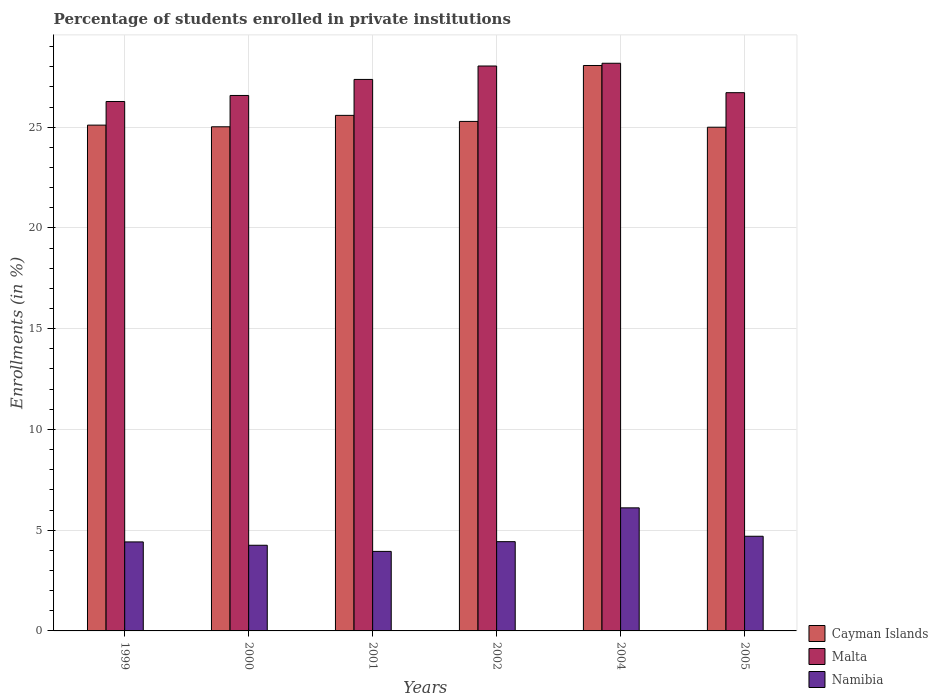How many different coloured bars are there?
Make the answer very short. 3. Are the number of bars on each tick of the X-axis equal?
Your response must be concise. Yes. How many bars are there on the 6th tick from the left?
Your answer should be compact. 3. How many bars are there on the 3rd tick from the right?
Keep it short and to the point. 3. What is the label of the 1st group of bars from the left?
Give a very brief answer. 1999. What is the percentage of trained teachers in Malta in 2004?
Offer a terse response. 28.17. Across all years, what is the maximum percentage of trained teachers in Cayman Islands?
Give a very brief answer. 28.06. Across all years, what is the minimum percentage of trained teachers in Namibia?
Provide a succinct answer. 3.95. In which year was the percentage of trained teachers in Namibia maximum?
Provide a succinct answer. 2004. In which year was the percentage of trained teachers in Malta minimum?
Offer a terse response. 1999. What is the total percentage of trained teachers in Cayman Islands in the graph?
Your response must be concise. 154.07. What is the difference between the percentage of trained teachers in Cayman Islands in 1999 and that in 2001?
Offer a very short reply. -0.48. What is the difference between the percentage of trained teachers in Malta in 2000 and the percentage of trained teachers in Cayman Islands in 2004?
Offer a very short reply. -1.49. What is the average percentage of trained teachers in Malta per year?
Ensure brevity in your answer.  27.19. In the year 2002, what is the difference between the percentage of trained teachers in Cayman Islands and percentage of trained teachers in Namibia?
Provide a short and direct response. 20.86. In how many years, is the percentage of trained teachers in Malta greater than 10 %?
Provide a short and direct response. 6. What is the ratio of the percentage of trained teachers in Cayman Islands in 1999 to that in 2004?
Ensure brevity in your answer.  0.89. Is the difference between the percentage of trained teachers in Cayman Islands in 2002 and 2004 greater than the difference between the percentage of trained teachers in Namibia in 2002 and 2004?
Your answer should be compact. No. What is the difference between the highest and the second highest percentage of trained teachers in Cayman Islands?
Your answer should be very brief. 2.48. What is the difference between the highest and the lowest percentage of trained teachers in Malta?
Your response must be concise. 1.9. Is the sum of the percentage of trained teachers in Malta in 2002 and 2005 greater than the maximum percentage of trained teachers in Namibia across all years?
Provide a short and direct response. Yes. What does the 1st bar from the left in 2002 represents?
Ensure brevity in your answer.  Cayman Islands. What does the 2nd bar from the right in 1999 represents?
Offer a terse response. Malta. Are all the bars in the graph horizontal?
Provide a succinct answer. No. How many years are there in the graph?
Your response must be concise. 6. Are the values on the major ticks of Y-axis written in scientific E-notation?
Make the answer very short. No. Does the graph contain any zero values?
Your answer should be compact. No. Does the graph contain grids?
Keep it short and to the point. Yes. How many legend labels are there?
Your answer should be compact. 3. What is the title of the graph?
Your answer should be very brief. Percentage of students enrolled in private institutions. Does "Turks and Caicos Islands" appear as one of the legend labels in the graph?
Ensure brevity in your answer.  No. What is the label or title of the X-axis?
Offer a terse response. Years. What is the label or title of the Y-axis?
Provide a succinct answer. Enrollments (in %). What is the Enrollments (in %) of Cayman Islands in 1999?
Keep it short and to the point. 25.1. What is the Enrollments (in %) in Malta in 1999?
Provide a succinct answer. 26.28. What is the Enrollments (in %) of Namibia in 1999?
Offer a terse response. 4.42. What is the Enrollments (in %) of Cayman Islands in 2000?
Your response must be concise. 25.02. What is the Enrollments (in %) in Malta in 2000?
Your answer should be compact. 26.58. What is the Enrollments (in %) of Namibia in 2000?
Provide a short and direct response. 4.25. What is the Enrollments (in %) in Cayman Islands in 2001?
Offer a very short reply. 25.59. What is the Enrollments (in %) in Malta in 2001?
Provide a short and direct response. 27.37. What is the Enrollments (in %) in Namibia in 2001?
Make the answer very short. 3.95. What is the Enrollments (in %) of Cayman Islands in 2002?
Keep it short and to the point. 25.29. What is the Enrollments (in %) of Malta in 2002?
Ensure brevity in your answer.  28.04. What is the Enrollments (in %) of Namibia in 2002?
Give a very brief answer. 4.43. What is the Enrollments (in %) in Cayman Islands in 2004?
Ensure brevity in your answer.  28.06. What is the Enrollments (in %) in Malta in 2004?
Ensure brevity in your answer.  28.17. What is the Enrollments (in %) in Namibia in 2004?
Provide a short and direct response. 6.11. What is the Enrollments (in %) in Malta in 2005?
Your answer should be compact. 26.71. What is the Enrollments (in %) of Namibia in 2005?
Give a very brief answer. 4.7. Across all years, what is the maximum Enrollments (in %) in Cayman Islands?
Your answer should be very brief. 28.06. Across all years, what is the maximum Enrollments (in %) of Malta?
Your response must be concise. 28.17. Across all years, what is the maximum Enrollments (in %) in Namibia?
Make the answer very short. 6.11. Across all years, what is the minimum Enrollments (in %) of Cayman Islands?
Your answer should be compact. 25. Across all years, what is the minimum Enrollments (in %) of Malta?
Provide a short and direct response. 26.28. Across all years, what is the minimum Enrollments (in %) in Namibia?
Offer a terse response. 3.95. What is the total Enrollments (in %) of Cayman Islands in the graph?
Make the answer very short. 154.07. What is the total Enrollments (in %) of Malta in the graph?
Your answer should be very brief. 163.15. What is the total Enrollments (in %) in Namibia in the graph?
Make the answer very short. 27.85. What is the difference between the Enrollments (in %) in Cayman Islands in 1999 and that in 2000?
Give a very brief answer. 0.08. What is the difference between the Enrollments (in %) in Malta in 1999 and that in 2000?
Make the answer very short. -0.3. What is the difference between the Enrollments (in %) of Namibia in 1999 and that in 2000?
Your answer should be compact. 0.17. What is the difference between the Enrollments (in %) of Cayman Islands in 1999 and that in 2001?
Keep it short and to the point. -0.48. What is the difference between the Enrollments (in %) in Malta in 1999 and that in 2001?
Provide a short and direct response. -1.09. What is the difference between the Enrollments (in %) of Namibia in 1999 and that in 2001?
Offer a terse response. 0.47. What is the difference between the Enrollments (in %) of Cayman Islands in 1999 and that in 2002?
Your answer should be very brief. -0.18. What is the difference between the Enrollments (in %) of Malta in 1999 and that in 2002?
Provide a succinct answer. -1.76. What is the difference between the Enrollments (in %) in Namibia in 1999 and that in 2002?
Your answer should be very brief. -0.01. What is the difference between the Enrollments (in %) of Cayman Islands in 1999 and that in 2004?
Ensure brevity in your answer.  -2.96. What is the difference between the Enrollments (in %) in Malta in 1999 and that in 2004?
Give a very brief answer. -1.9. What is the difference between the Enrollments (in %) of Namibia in 1999 and that in 2004?
Ensure brevity in your answer.  -1.69. What is the difference between the Enrollments (in %) in Cayman Islands in 1999 and that in 2005?
Provide a succinct answer. 0.1. What is the difference between the Enrollments (in %) in Malta in 1999 and that in 2005?
Your response must be concise. -0.44. What is the difference between the Enrollments (in %) of Namibia in 1999 and that in 2005?
Offer a very short reply. -0.28. What is the difference between the Enrollments (in %) of Cayman Islands in 2000 and that in 2001?
Keep it short and to the point. -0.57. What is the difference between the Enrollments (in %) in Malta in 2000 and that in 2001?
Give a very brief answer. -0.8. What is the difference between the Enrollments (in %) of Namibia in 2000 and that in 2001?
Give a very brief answer. 0.3. What is the difference between the Enrollments (in %) in Cayman Islands in 2000 and that in 2002?
Give a very brief answer. -0.27. What is the difference between the Enrollments (in %) of Malta in 2000 and that in 2002?
Ensure brevity in your answer.  -1.46. What is the difference between the Enrollments (in %) of Namibia in 2000 and that in 2002?
Provide a succinct answer. -0.18. What is the difference between the Enrollments (in %) of Cayman Islands in 2000 and that in 2004?
Your answer should be very brief. -3.04. What is the difference between the Enrollments (in %) of Malta in 2000 and that in 2004?
Offer a terse response. -1.6. What is the difference between the Enrollments (in %) in Namibia in 2000 and that in 2004?
Your answer should be compact. -1.86. What is the difference between the Enrollments (in %) of Cayman Islands in 2000 and that in 2005?
Ensure brevity in your answer.  0.02. What is the difference between the Enrollments (in %) of Malta in 2000 and that in 2005?
Your answer should be compact. -0.14. What is the difference between the Enrollments (in %) in Namibia in 2000 and that in 2005?
Your answer should be very brief. -0.45. What is the difference between the Enrollments (in %) in Malta in 2001 and that in 2002?
Offer a terse response. -0.67. What is the difference between the Enrollments (in %) in Namibia in 2001 and that in 2002?
Offer a very short reply. -0.48. What is the difference between the Enrollments (in %) in Cayman Islands in 2001 and that in 2004?
Provide a succinct answer. -2.48. What is the difference between the Enrollments (in %) in Malta in 2001 and that in 2004?
Ensure brevity in your answer.  -0.8. What is the difference between the Enrollments (in %) of Namibia in 2001 and that in 2004?
Provide a short and direct response. -2.16. What is the difference between the Enrollments (in %) of Cayman Islands in 2001 and that in 2005?
Ensure brevity in your answer.  0.59. What is the difference between the Enrollments (in %) in Malta in 2001 and that in 2005?
Provide a succinct answer. 0.66. What is the difference between the Enrollments (in %) of Namibia in 2001 and that in 2005?
Provide a short and direct response. -0.75. What is the difference between the Enrollments (in %) in Cayman Islands in 2002 and that in 2004?
Make the answer very short. -2.78. What is the difference between the Enrollments (in %) of Malta in 2002 and that in 2004?
Provide a succinct answer. -0.14. What is the difference between the Enrollments (in %) in Namibia in 2002 and that in 2004?
Offer a very short reply. -1.68. What is the difference between the Enrollments (in %) of Cayman Islands in 2002 and that in 2005?
Keep it short and to the point. 0.29. What is the difference between the Enrollments (in %) in Malta in 2002 and that in 2005?
Your answer should be very brief. 1.32. What is the difference between the Enrollments (in %) of Namibia in 2002 and that in 2005?
Provide a succinct answer. -0.27. What is the difference between the Enrollments (in %) of Cayman Islands in 2004 and that in 2005?
Offer a terse response. 3.06. What is the difference between the Enrollments (in %) in Malta in 2004 and that in 2005?
Offer a very short reply. 1.46. What is the difference between the Enrollments (in %) in Namibia in 2004 and that in 2005?
Keep it short and to the point. 1.41. What is the difference between the Enrollments (in %) of Cayman Islands in 1999 and the Enrollments (in %) of Malta in 2000?
Make the answer very short. -1.47. What is the difference between the Enrollments (in %) of Cayman Islands in 1999 and the Enrollments (in %) of Namibia in 2000?
Make the answer very short. 20.85. What is the difference between the Enrollments (in %) of Malta in 1999 and the Enrollments (in %) of Namibia in 2000?
Your answer should be compact. 22.03. What is the difference between the Enrollments (in %) in Cayman Islands in 1999 and the Enrollments (in %) in Malta in 2001?
Ensure brevity in your answer.  -2.27. What is the difference between the Enrollments (in %) of Cayman Islands in 1999 and the Enrollments (in %) of Namibia in 2001?
Give a very brief answer. 21.16. What is the difference between the Enrollments (in %) in Malta in 1999 and the Enrollments (in %) in Namibia in 2001?
Your answer should be compact. 22.33. What is the difference between the Enrollments (in %) of Cayman Islands in 1999 and the Enrollments (in %) of Malta in 2002?
Offer a very short reply. -2.93. What is the difference between the Enrollments (in %) of Cayman Islands in 1999 and the Enrollments (in %) of Namibia in 2002?
Offer a very short reply. 20.67. What is the difference between the Enrollments (in %) of Malta in 1999 and the Enrollments (in %) of Namibia in 2002?
Your answer should be compact. 21.85. What is the difference between the Enrollments (in %) of Cayman Islands in 1999 and the Enrollments (in %) of Malta in 2004?
Offer a terse response. -3.07. What is the difference between the Enrollments (in %) of Cayman Islands in 1999 and the Enrollments (in %) of Namibia in 2004?
Make the answer very short. 19. What is the difference between the Enrollments (in %) of Malta in 1999 and the Enrollments (in %) of Namibia in 2004?
Provide a short and direct response. 20.17. What is the difference between the Enrollments (in %) of Cayman Islands in 1999 and the Enrollments (in %) of Malta in 2005?
Make the answer very short. -1.61. What is the difference between the Enrollments (in %) of Cayman Islands in 1999 and the Enrollments (in %) of Namibia in 2005?
Offer a very short reply. 20.41. What is the difference between the Enrollments (in %) in Malta in 1999 and the Enrollments (in %) in Namibia in 2005?
Make the answer very short. 21.58. What is the difference between the Enrollments (in %) in Cayman Islands in 2000 and the Enrollments (in %) in Malta in 2001?
Provide a short and direct response. -2.35. What is the difference between the Enrollments (in %) of Cayman Islands in 2000 and the Enrollments (in %) of Namibia in 2001?
Make the answer very short. 21.07. What is the difference between the Enrollments (in %) in Malta in 2000 and the Enrollments (in %) in Namibia in 2001?
Provide a succinct answer. 22.63. What is the difference between the Enrollments (in %) in Cayman Islands in 2000 and the Enrollments (in %) in Malta in 2002?
Make the answer very short. -3.02. What is the difference between the Enrollments (in %) of Cayman Islands in 2000 and the Enrollments (in %) of Namibia in 2002?
Provide a short and direct response. 20.59. What is the difference between the Enrollments (in %) in Malta in 2000 and the Enrollments (in %) in Namibia in 2002?
Keep it short and to the point. 22.15. What is the difference between the Enrollments (in %) in Cayman Islands in 2000 and the Enrollments (in %) in Malta in 2004?
Your answer should be very brief. -3.15. What is the difference between the Enrollments (in %) in Cayman Islands in 2000 and the Enrollments (in %) in Namibia in 2004?
Provide a short and direct response. 18.91. What is the difference between the Enrollments (in %) in Malta in 2000 and the Enrollments (in %) in Namibia in 2004?
Offer a terse response. 20.47. What is the difference between the Enrollments (in %) in Cayman Islands in 2000 and the Enrollments (in %) in Malta in 2005?
Provide a short and direct response. -1.69. What is the difference between the Enrollments (in %) of Cayman Islands in 2000 and the Enrollments (in %) of Namibia in 2005?
Provide a succinct answer. 20.32. What is the difference between the Enrollments (in %) in Malta in 2000 and the Enrollments (in %) in Namibia in 2005?
Your response must be concise. 21.88. What is the difference between the Enrollments (in %) of Cayman Islands in 2001 and the Enrollments (in %) of Malta in 2002?
Give a very brief answer. -2.45. What is the difference between the Enrollments (in %) in Cayman Islands in 2001 and the Enrollments (in %) in Namibia in 2002?
Keep it short and to the point. 21.16. What is the difference between the Enrollments (in %) in Malta in 2001 and the Enrollments (in %) in Namibia in 2002?
Your answer should be compact. 22.94. What is the difference between the Enrollments (in %) of Cayman Islands in 2001 and the Enrollments (in %) of Malta in 2004?
Your answer should be compact. -2.59. What is the difference between the Enrollments (in %) in Cayman Islands in 2001 and the Enrollments (in %) in Namibia in 2004?
Give a very brief answer. 19.48. What is the difference between the Enrollments (in %) in Malta in 2001 and the Enrollments (in %) in Namibia in 2004?
Give a very brief answer. 21.26. What is the difference between the Enrollments (in %) of Cayman Islands in 2001 and the Enrollments (in %) of Malta in 2005?
Offer a terse response. -1.13. What is the difference between the Enrollments (in %) in Cayman Islands in 2001 and the Enrollments (in %) in Namibia in 2005?
Give a very brief answer. 20.89. What is the difference between the Enrollments (in %) of Malta in 2001 and the Enrollments (in %) of Namibia in 2005?
Keep it short and to the point. 22.67. What is the difference between the Enrollments (in %) of Cayman Islands in 2002 and the Enrollments (in %) of Malta in 2004?
Provide a succinct answer. -2.89. What is the difference between the Enrollments (in %) in Cayman Islands in 2002 and the Enrollments (in %) in Namibia in 2004?
Give a very brief answer. 19.18. What is the difference between the Enrollments (in %) in Malta in 2002 and the Enrollments (in %) in Namibia in 2004?
Provide a short and direct response. 21.93. What is the difference between the Enrollments (in %) in Cayman Islands in 2002 and the Enrollments (in %) in Malta in 2005?
Your answer should be very brief. -1.43. What is the difference between the Enrollments (in %) of Cayman Islands in 2002 and the Enrollments (in %) of Namibia in 2005?
Provide a short and direct response. 20.59. What is the difference between the Enrollments (in %) in Malta in 2002 and the Enrollments (in %) in Namibia in 2005?
Offer a terse response. 23.34. What is the difference between the Enrollments (in %) of Cayman Islands in 2004 and the Enrollments (in %) of Malta in 2005?
Keep it short and to the point. 1.35. What is the difference between the Enrollments (in %) in Cayman Islands in 2004 and the Enrollments (in %) in Namibia in 2005?
Provide a short and direct response. 23.37. What is the difference between the Enrollments (in %) in Malta in 2004 and the Enrollments (in %) in Namibia in 2005?
Offer a terse response. 23.48. What is the average Enrollments (in %) of Cayman Islands per year?
Offer a very short reply. 25.68. What is the average Enrollments (in %) of Malta per year?
Keep it short and to the point. 27.19. What is the average Enrollments (in %) of Namibia per year?
Your answer should be very brief. 4.64. In the year 1999, what is the difference between the Enrollments (in %) of Cayman Islands and Enrollments (in %) of Malta?
Ensure brevity in your answer.  -1.17. In the year 1999, what is the difference between the Enrollments (in %) of Cayman Islands and Enrollments (in %) of Namibia?
Offer a terse response. 20.69. In the year 1999, what is the difference between the Enrollments (in %) in Malta and Enrollments (in %) in Namibia?
Provide a succinct answer. 21.86. In the year 2000, what is the difference between the Enrollments (in %) of Cayman Islands and Enrollments (in %) of Malta?
Give a very brief answer. -1.55. In the year 2000, what is the difference between the Enrollments (in %) in Cayman Islands and Enrollments (in %) in Namibia?
Ensure brevity in your answer.  20.77. In the year 2000, what is the difference between the Enrollments (in %) in Malta and Enrollments (in %) in Namibia?
Offer a terse response. 22.32. In the year 2001, what is the difference between the Enrollments (in %) in Cayman Islands and Enrollments (in %) in Malta?
Ensure brevity in your answer.  -1.78. In the year 2001, what is the difference between the Enrollments (in %) of Cayman Islands and Enrollments (in %) of Namibia?
Make the answer very short. 21.64. In the year 2001, what is the difference between the Enrollments (in %) in Malta and Enrollments (in %) in Namibia?
Your answer should be very brief. 23.42. In the year 2002, what is the difference between the Enrollments (in %) of Cayman Islands and Enrollments (in %) of Malta?
Ensure brevity in your answer.  -2.75. In the year 2002, what is the difference between the Enrollments (in %) in Cayman Islands and Enrollments (in %) in Namibia?
Your answer should be compact. 20.86. In the year 2002, what is the difference between the Enrollments (in %) in Malta and Enrollments (in %) in Namibia?
Your answer should be compact. 23.61. In the year 2004, what is the difference between the Enrollments (in %) of Cayman Islands and Enrollments (in %) of Malta?
Keep it short and to the point. -0.11. In the year 2004, what is the difference between the Enrollments (in %) in Cayman Islands and Enrollments (in %) in Namibia?
Make the answer very short. 21.96. In the year 2004, what is the difference between the Enrollments (in %) of Malta and Enrollments (in %) of Namibia?
Make the answer very short. 22.07. In the year 2005, what is the difference between the Enrollments (in %) of Cayman Islands and Enrollments (in %) of Malta?
Offer a very short reply. -1.71. In the year 2005, what is the difference between the Enrollments (in %) of Cayman Islands and Enrollments (in %) of Namibia?
Your answer should be very brief. 20.3. In the year 2005, what is the difference between the Enrollments (in %) of Malta and Enrollments (in %) of Namibia?
Your response must be concise. 22.02. What is the ratio of the Enrollments (in %) of Malta in 1999 to that in 2000?
Give a very brief answer. 0.99. What is the ratio of the Enrollments (in %) of Namibia in 1999 to that in 2000?
Make the answer very short. 1.04. What is the ratio of the Enrollments (in %) in Cayman Islands in 1999 to that in 2001?
Your response must be concise. 0.98. What is the ratio of the Enrollments (in %) in Malta in 1999 to that in 2001?
Provide a succinct answer. 0.96. What is the ratio of the Enrollments (in %) in Namibia in 1999 to that in 2001?
Ensure brevity in your answer.  1.12. What is the ratio of the Enrollments (in %) in Malta in 1999 to that in 2002?
Offer a very short reply. 0.94. What is the ratio of the Enrollments (in %) of Namibia in 1999 to that in 2002?
Offer a terse response. 1. What is the ratio of the Enrollments (in %) of Cayman Islands in 1999 to that in 2004?
Your response must be concise. 0.89. What is the ratio of the Enrollments (in %) of Malta in 1999 to that in 2004?
Provide a short and direct response. 0.93. What is the ratio of the Enrollments (in %) of Namibia in 1999 to that in 2004?
Ensure brevity in your answer.  0.72. What is the ratio of the Enrollments (in %) in Cayman Islands in 1999 to that in 2005?
Offer a terse response. 1. What is the ratio of the Enrollments (in %) of Malta in 1999 to that in 2005?
Keep it short and to the point. 0.98. What is the ratio of the Enrollments (in %) of Namibia in 1999 to that in 2005?
Offer a very short reply. 0.94. What is the ratio of the Enrollments (in %) of Cayman Islands in 2000 to that in 2001?
Make the answer very short. 0.98. What is the ratio of the Enrollments (in %) in Malta in 2000 to that in 2001?
Provide a short and direct response. 0.97. What is the ratio of the Enrollments (in %) in Namibia in 2000 to that in 2001?
Your answer should be very brief. 1.08. What is the ratio of the Enrollments (in %) of Cayman Islands in 2000 to that in 2002?
Provide a short and direct response. 0.99. What is the ratio of the Enrollments (in %) of Malta in 2000 to that in 2002?
Make the answer very short. 0.95. What is the ratio of the Enrollments (in %) in Namibia in 2000 to that in 2002?
Your response must be concise. 0.96. What is the ratio of the Enrollments (in %) in Cayman Islands in 2000 to that in 2004?
Ensure brevity in your answer.  0.89. What is the ratio of the Enrollments (in %) in Malta in 2000 to that in 2004?
Provide a short and direct response. 0.94. What is the ratio of the Enrollments (in %) in Namibia in 2000 to that in 2004?
Your answer should be very brief. 0.7. What is the ratio of the Enrollments (in %) of Cayman Islands in 2000 to that in 2005?
Offer a terse response. 1. What is the ratio of the Enrollments (in %) in Namibia in 2000 to that in 2005?
Ensure brevity in your answer.  0.9. What is the ratio of the Enrollments (in %) of Cayman Islands in 2001 to that in 2002?
Make the answer very short. 1.01. What is the ratio of the Enrollments (in %) in Malta in 2001 to that in 2002?
Give a very brief answer. 0.98. What is the ratio of the Enrollments (in %) of Namibia in 2001 to that in 2002?
Offer a very short reply. 0.89. What is the ratio of the Enrollments (in %) in Cayman Islands in 2001 to that in 2004?
Provide a succinct answer. 0.91. What is the ratio of the Enrollments (in %) of Malta in 2001 to that in 2004?
Your answer should be very brief. 0.97. What is the ratio of the Enrollments (in %) in Namibia in 2001 to that in 2004?
Make the answer very short. 0.65. What is the ratio of the Enrollments (in %) of Cayman Islands in 2001 to that in 2005?
Your answer should be compact. 1.02. What is the ratio of the Enrollments (in %) of Malta in 2001 to that in 2005?
Offer a very short reply. 1.02. What is the ratio of the Enrollments (in %) of Namibia in 2001 to that in 2005?
Offer a terse response. 0.84. What is the ratio of the Enrollments (in %) in Cayman Islands in 2002 to that in 2004?
Give a very brief answer. 0.9. What is the ratio of the Enrollments (in %) of Malta in 2002 to that in 2004?
Your answer should be compact. 1. What is the ratio of the Enrollments (in %) in Namibia in 2002 to that in 2004?
Offer a terse response. 0.73. What is the ratio of the Enrollments (in %) in Cayman Islands in 2002 to that in 2005?
Your answer should be very brief. 1.01. What is the ratio of the Enrollments (in %) of Malta in 2002 to that in 2005?
Provide a short and direct response. 1.05. What is the ratio of the Enrollments (in %) of Namibia in 2002 to that in 2005?
Give a very brief answer. 0.94. What is the ratio of the Enrollments (in %) of Cayman Islands in 2004 to that in 2005?
Provide a succinct answer. 1.12. What is the ratio of the Enrollments (in %) in Malta in 2004 to that in 2005?
Offer a terse response. 1.05. What is the ratio of the Enrollments (in %) in Namibia in 2004 to that in 2005?
Make the answer very short. 1.3. What is the difference between the highest and the second highest Enrollments (in %) in Cayman Islands?
Your response must be concise. 2.48. What is the difference between the highest and the second highest Enrollments (in %) of Malta?
Your answer should be very brief. 0.14. What is the difference between the highest and the second highest Enrollments (in %) of Namibia?
Offer a very short reply. 1.41. What is the difference between the highest and the lowest Enrollments (in %) in Cayman Islands?
Offer a terse response. 3.06. What is the difference between the highest and the lowest Enrollments (in %) of Malta?
Your response must be concise. 1.9. What is the difference between the highest and the lowest Enrollments (in %) of Namibia?
Offer a very short reply. 2.16. 